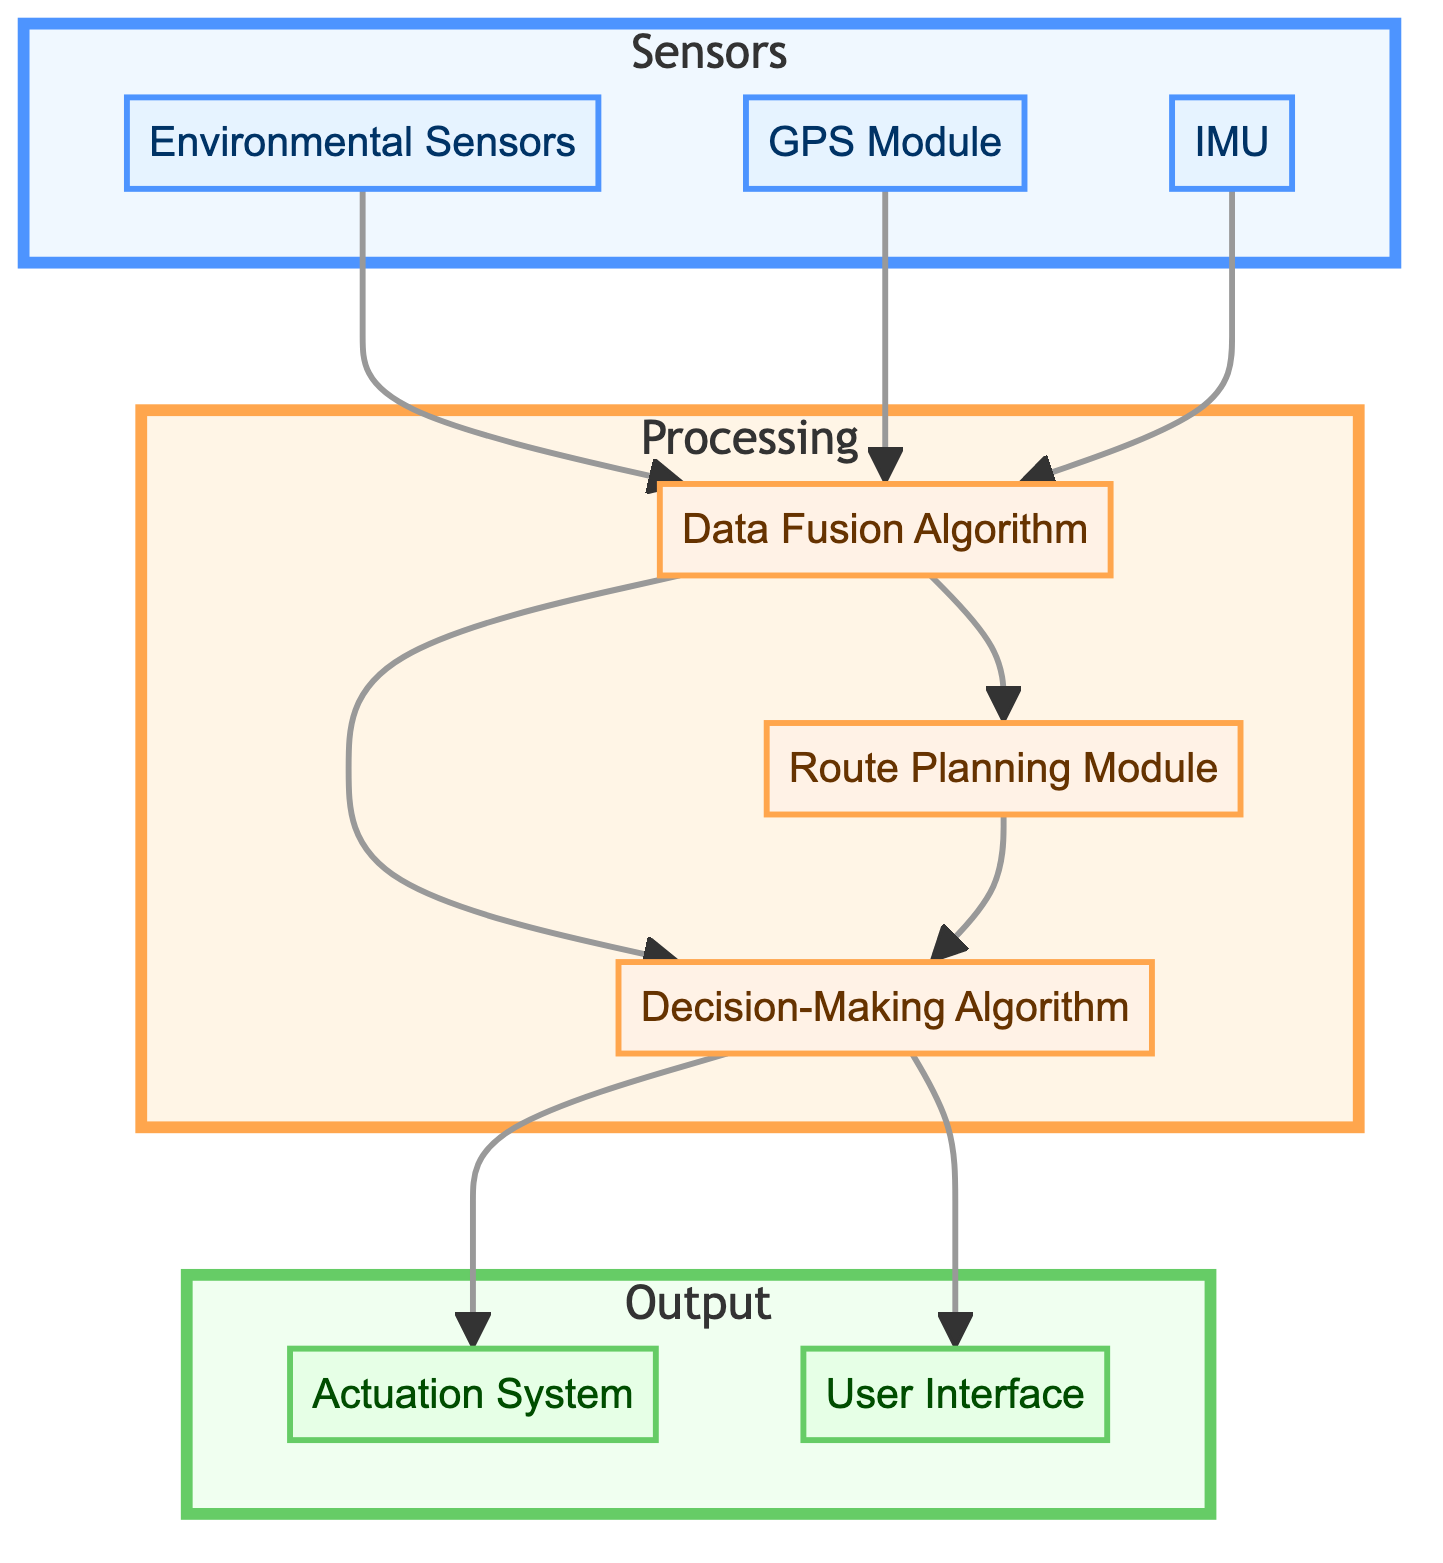What are the three types of components in this diagram? The diagram includes three distinct types of components: Sensors, Processing, and Output. These categories represent different functions within the automated navigation system.
Answer: Sensors, Processing, Output Which component receives data from the Environmental Sensors? The Environmental Sensors send data to the Data Fusion Algorithm, which is responsible for integrating information from various sensors. This relationship is indicated by an arrow pointing from the Environmental Sensors to the Data Fusion Algorithm.
Answer: Data Fusion Algorithm How many sensors are depicted in the diagram? There are three sensors illustrated in the diagram: Environmental Sensors, GPS Module, and IMU. This count can be confirmed by counting the components in the Sensors subgraph.
Answer: 3 What is the role of the Decision-Making Algorithm? The Decision-Making Algorithm processes the data that has been fused and the planned route to make navigation decisions, as indicated by its connections to the other components.
Answer: Navigation decisions Which component sends data to both the Actuation System and the User Interface? The Decision-Making Algorithm is the component that sends data to both the Actuation System and the User Interface, which can be verified by following the arrows leading from it to these two output components.
Answer: Decision-Making Algorithm Based on the diagram, what process occurs after data from the sensors is fused? After the data from the sensors is fused by the Data Fusion Algorithm, it is sent to both the Route Planning Module and the Decision-Making Algorithm. This sequence of operations can be traced through the connections in the Processing subgraph.
Answer: Route Planning Module and Decision-Making Algorithm What is the sequence of operations starting from the GPS Module? The GPS Module first provides data to the Data Fusion Algorithm, which then passes this information to the Decision-Making Algorithm after integrating it with data from other sensors. This involves following the directional arrows in the diagram to see the data flow.
Answer: Data Fusion Algorithm, Decision-Making Algorithm Which two components interact directly before making navigation decisions? The Decision-Making Algorithm interacts with the Route Planning Module and receives integrated data from the Data Fusion Algorithm. This interaction is shown by the arrows connecting these components in the Processing subgraph.
Answer: Decision-Making Algorithm and Route Planning Module 